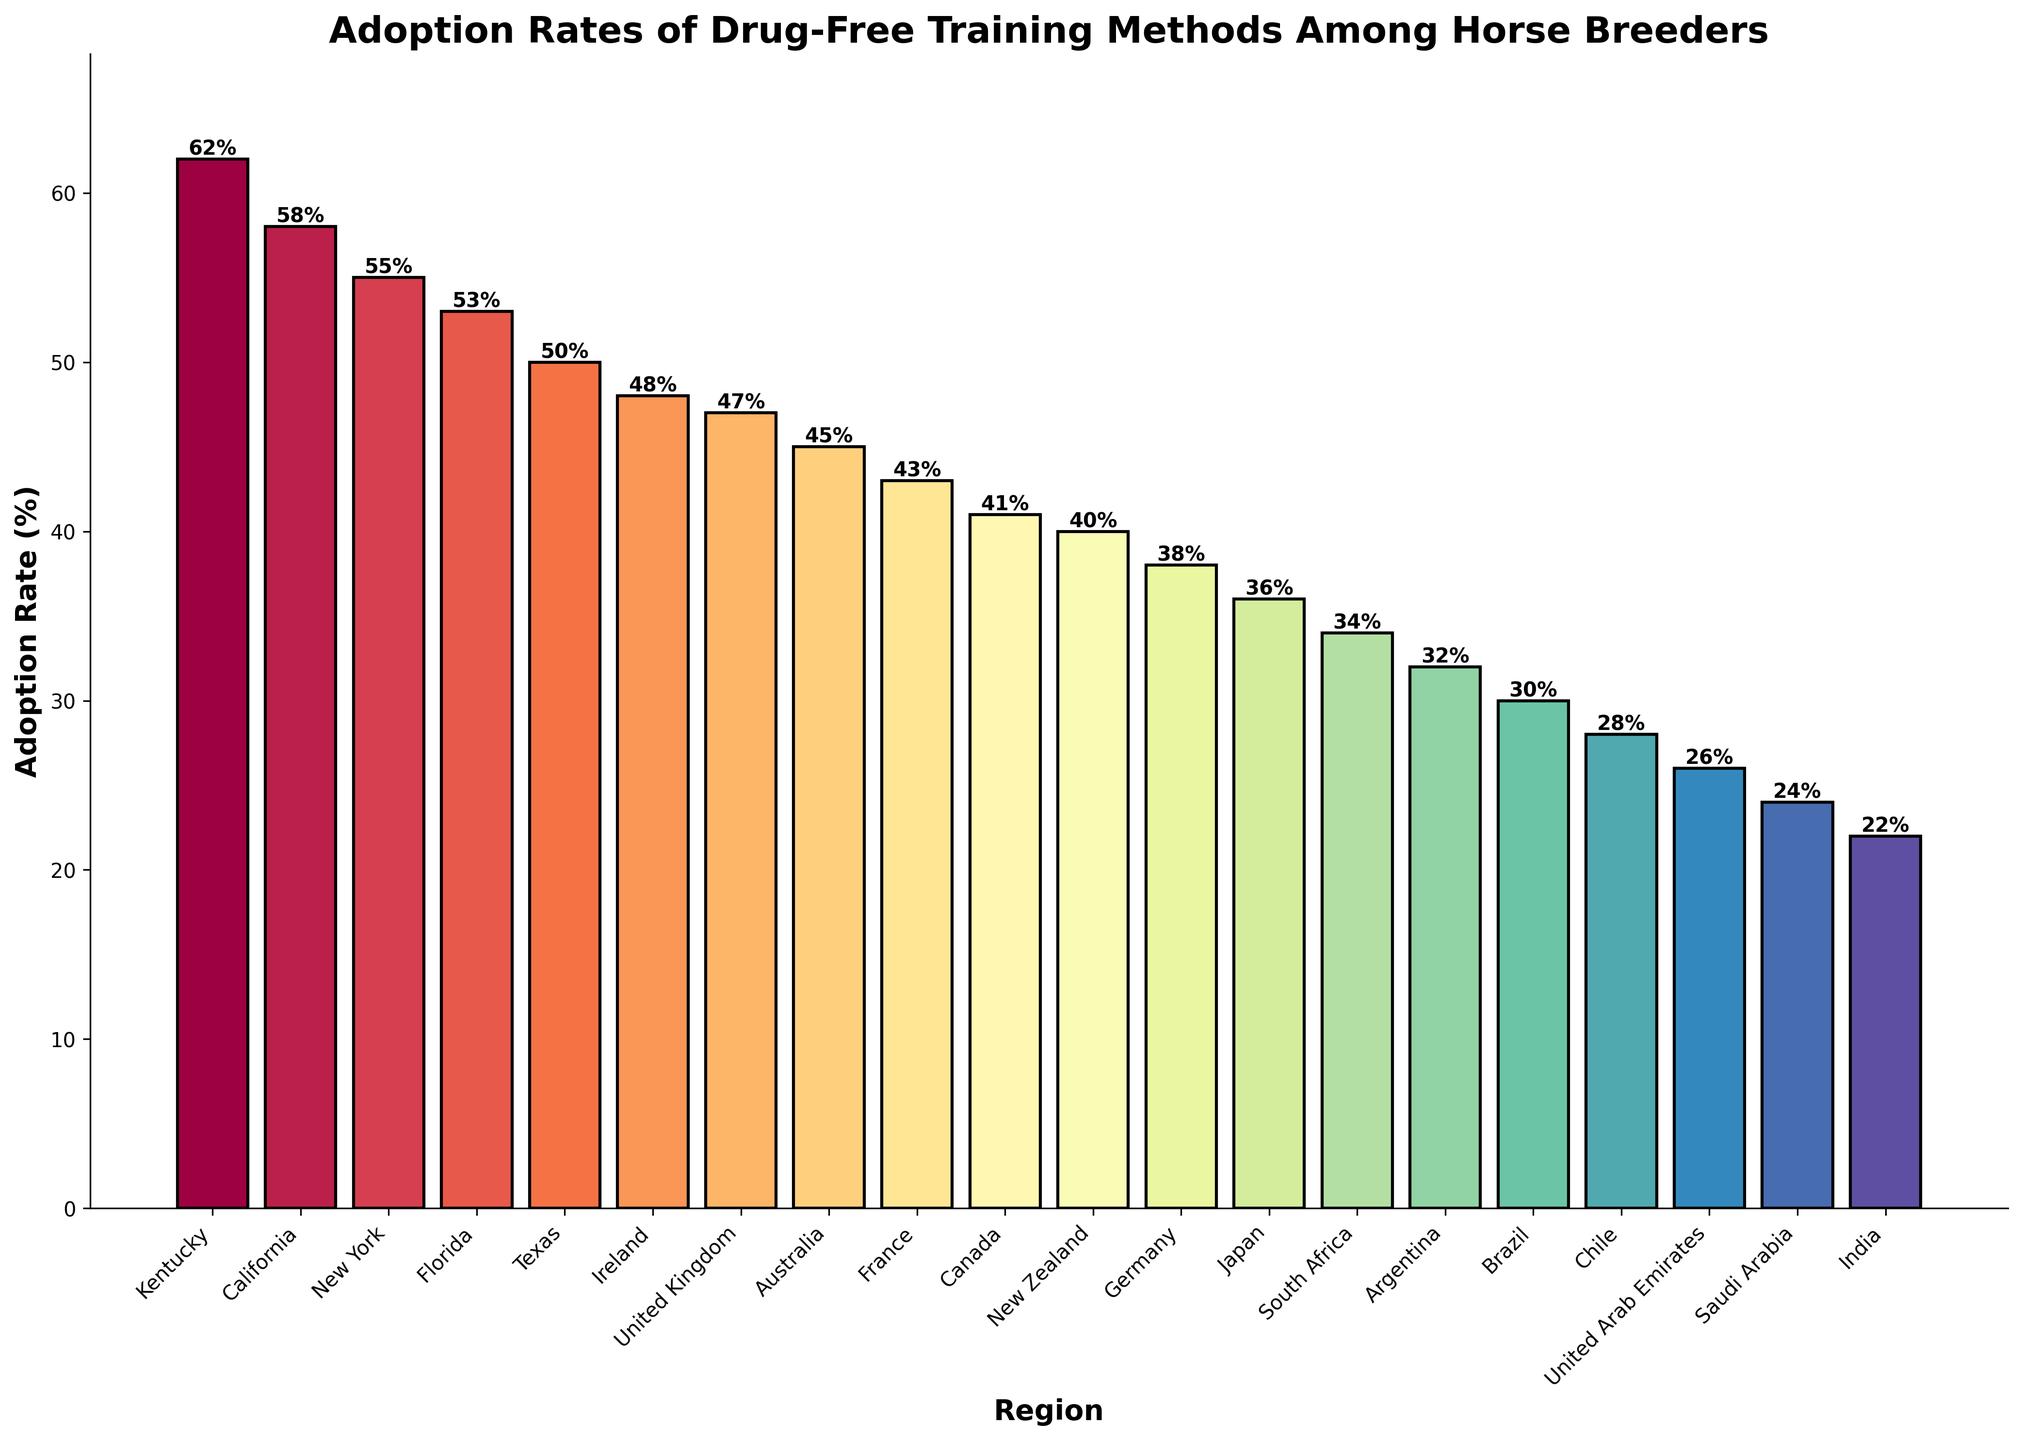What's the highest adoption rate? The highest adoption rate is the tallest bar in the chart which represents Kentucky with 62%.
Answer: 62% Which region has the lowest adoption rate? The lowest adoption rate is represented by the shortest bar in the chart which corresponds to India with 22%.
Answer: India How many regions have an adoption rate above 50%? Count all the bars with heights over 50%. There are 5 such regions: Kentucky, California, New York, Florida, and Texas.
Answer: 5 regions What is the average adoption rate of the top three regions? The top three regions are Kentucky (62%), California (58%), and New York (55%). Calculate the average: (62 + 58 + 55) / 3 = 175 / 3 = 58.33%.
Answer: 58.33% Which region has an adoption rate closest to 40%? From the chart, Canada has an adoption rate of 41%, which is closest to 40%.
Answer: Canada Compare the adoption rates of France and Australia. Which one is higher and by how much? France has an adoption rate of 43%, while Australia has 45%. Australia has a higher adoption rate by 2%.
Answer: Australia, 2% What is the difference in adoption rates between New Zealand and Japan? New Zealand has an adoption rate of 40%, while Japan has 36%. The difference is 40% - 36% = 4%.
Answer: 4% Determine the median adoption rate. The regions arranged by adoption rate are: [22, 24, 26, 28, 30, 32, 34, 36, 38, 40, 41, 43, 45, 47, 48, 50, 53, 55, 58, 62]. The median is the average of the 10th and 11th values. (40 + 41) / 2 = 40.5%.
Answer: 40.5% Which regions have the same color shade? Referring to the colormap, regions that are close in the sequence will have similar shades. For example, Canada and New Zealand both have a close shade as they appear consecutively.
Answer: Canada and New Zealand 